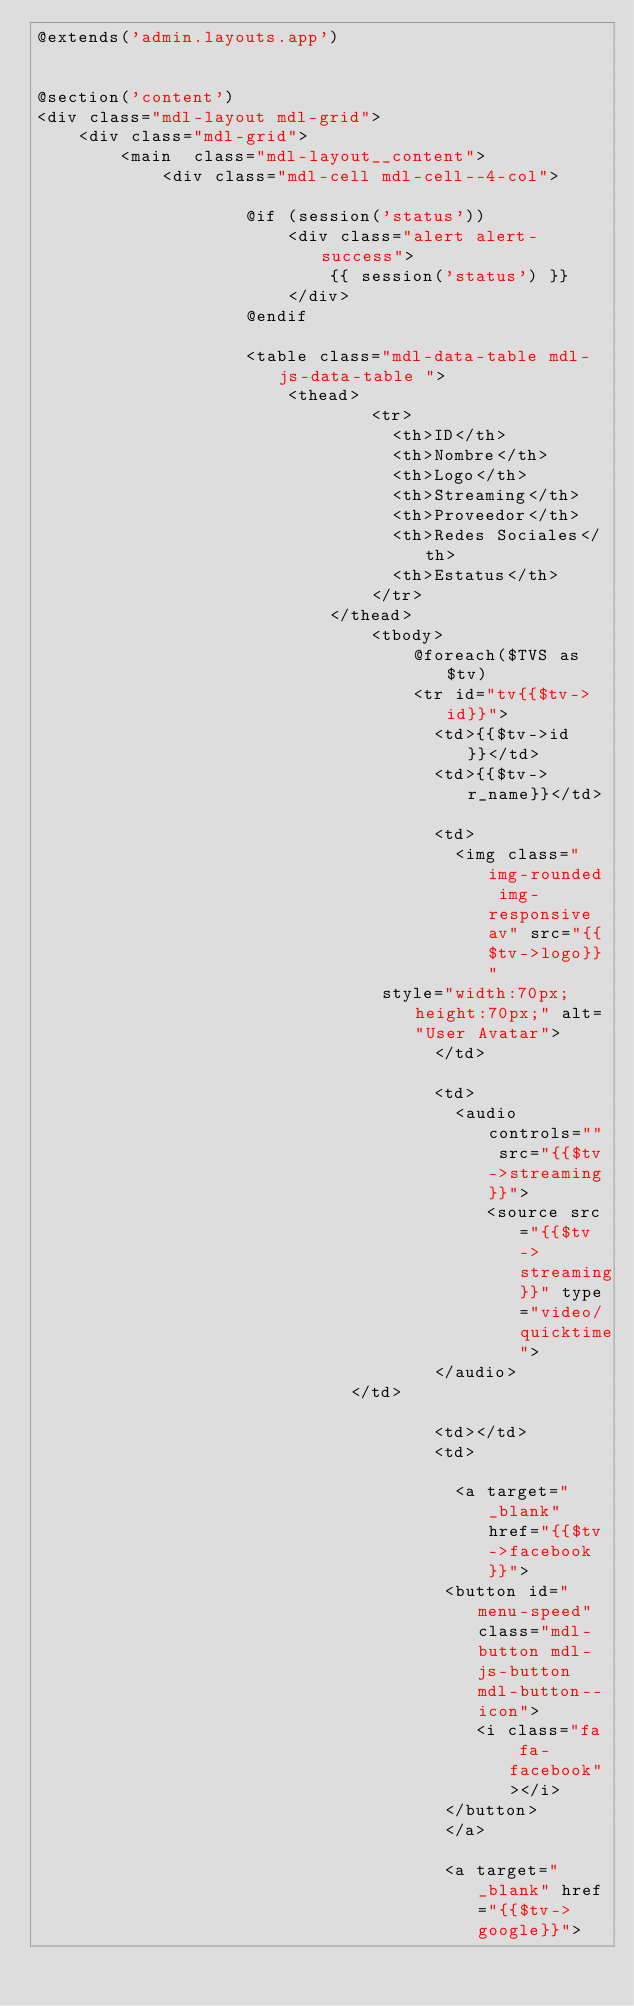Convert code to text. <code><loc_0><loc_0><loc_500><loc_500><_PHP_>@extends('admin.layouts.app')


@section('content')
<div class="mdl-layout mdl-grid">
    <div class="mdl-grid">
        <main  class="mdl-layout__content">
            <div class="mdl-cell mdl-cell--4-col">

                    @if (session('status'))
                        <div class="alert alert-success">
                            {{ session('status') }}
                        </div>
                    @endif

                    <table class="mdl-data-table mdl-js-data-table ">            
                        <thead>
                                <tr>
                                  <th>ID</th>
                                  <th>Nombre</th>
                                  <th>Logo</th>
                                  <th>Streaming</th>
                                  <th>Proveedor</th>
                                  <th>Redes Sociales</th>
                                  <th>Estatus</th>
                                </tr>
                            </thead>
                                <tbody>
                                    @foreach($TVS as $tv)
                                    <tr id="tv{{$tv->id}}">
                                      <td>{{$tv->id}}</td>
                                      <td>{{$tv->r_name}}</td>

                                      <td>
                                        <img class="img-rounded img-responsive av" src="{{$tv->logo}}"
                                 style="width:70px;height:70px;" alt="User Avatar">
                                      </td>

                                      <td>
                                        <audio controls="" src="{{$tv->streaming}}">
                                           <source src="{{$tv->streaming}}" type="video/quicktime">
                                      </audio>
                              </td>
                                      
                                      <td></td>
                                      <td>
                                       
                                        <a target="_blank" href="{{$tv->facebook}}">
                                       <button id="menu-speed" class="mdl-button mdl-js-button mdl-button--icon">
                                          <i class="fa fa-facebook"></i>
                                       </button>
                                       </a>

                                       <a target="_blank" href="{{$tv->google}}"></code> 